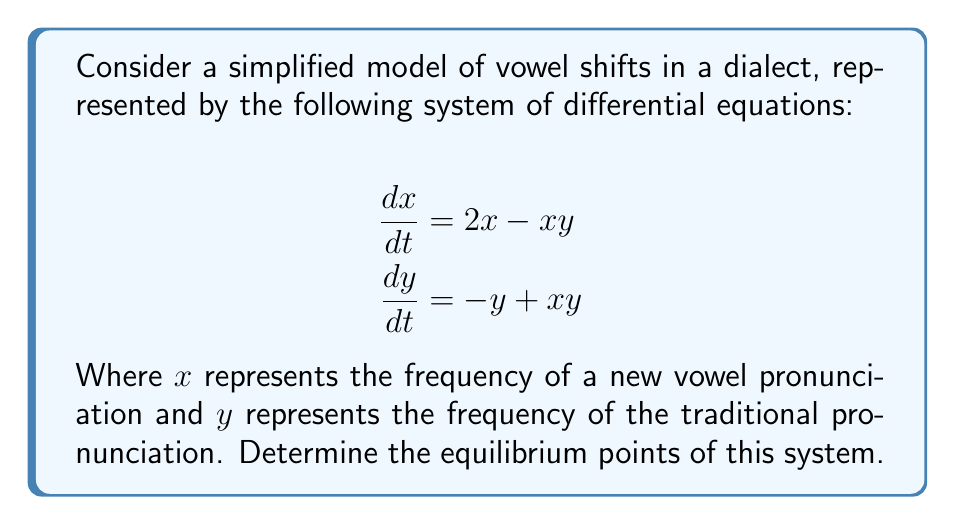Can you solve this math problem? To find the equilibrium points, we need to set both derivatives equal to zero and solve the resulting system of equations:

1) Set $\frac{dx}{dt} = 0$ and $\frac{dy}{dt} = 0$:
   $$\begin{align}
   2x - xy &= 0 \\
   -y + xy &= 0
   \end{align}$$

2) From the first equation:
   $x(2 - y) = 0$
   This implies either $x = 0$ or $y = 2$

3) From the second equation:
   $y(x - 1) = 0$
   This implies either $y = 0$ or $x = 1$

4) Combining these results:
   a) If $x = 0$, then from the second equation, $y = 0$
   b) If $y = 2$, then from the second equation, $x = 1$
   c) If $y = 0$, then from the first equation, $x = 0$ (already covered in case a)
   d) If $x = 1$, then from the first equation, $y = 2$ (already covered in case b)

5) Therefore, we have two equilibrium points:
   $(0, 0)$ and $(1, 2)$

These points represent:
- $(0, 0)$: Neither pronunciation is used
- $(1, 2)$: Both pronunciations coexist, with the traditional form used twice as frequently as the new form
Answer: $(0, 0)$ and $(1, 2)$ 